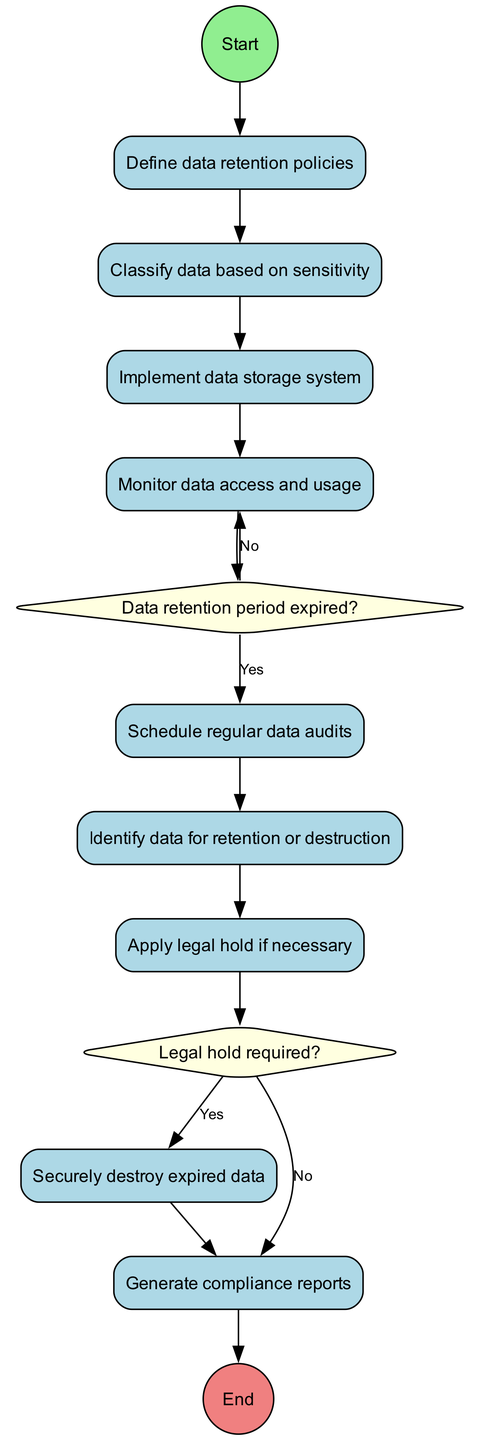What is the first activity in the diagram? The diagram starts at the "Start" node which leads directly to the first activity, "Define data retention policies."
Answer: Define data retention policies How many activities are present in the diagram? The diagram includes a list of 9 activities that are represented as nodes following the initial node and prior to the final node.
Answer: 9 What node follows "Monitor data access and usage"? From the diagram's flow, after "Monitor data access and usage," the flow splits into a decision node where it asks if the data retention period has expired.
Answer: Decision node What decision is asked immediately after "Identify data for retention or destruction"? Directly after the "Identify data for retention or destruction" activity, the diagram poses the question, "Legal hold required?" indicating the decision to be made.
Answer: Legal hold required If the data retention period has not expired, what is the next activity? According to the diagram, if the data retention period has not expired (the "No" path from the decision), the next action is "Monitor data access and usage."
Answer: Monitor data access and usage What action is taken if a legal hold is required? When a legal hold is indicated as required (the "Yes" path from the decision node), the next action specified in the diagram is to "Apply legal hold if necessary."
Answer: Apply legal hold if necessary How is expired data handled if no legal hold is needed? If no legal hold is required, the next step in the sequence shows that expired data is handled by "Securely destroy expired data."
Answer: Securely destroy expired data What is the final step in the diagram? The flow of the diagram ends with the final node labeled "End," which concludes the activities and decisions detailed within the diagram.
Answer: End 